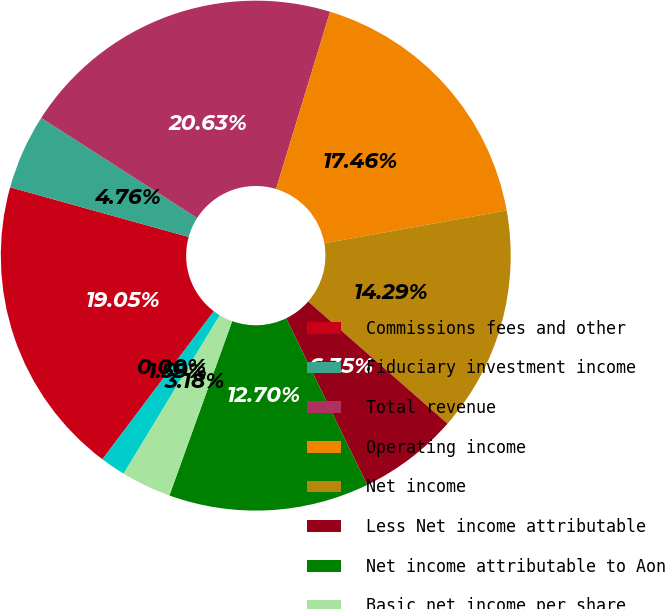<chart> <loc_0><loc_0><loc_500><loc_500><pie_chart><fcel>Commissions fees and other<fcel>Fiduciary investment income<fcel>Total revenue<fcel>Operating income<fcel>Net income<fcel>Less Net income attributable<fcel>Net income attributable to Aon<fcel>Basic net income per share<fcel>Diluted net income per share<fcel>Dividends paid per share<nl><fcel>19.05%<fcel>4.76%<fcel>20.63%<fcel>17.46%<fcel>14.29%<fcel>6.35%<fcel>12.7%<fcel>3.18%<fcel>1.59%<fcel>0.0%<nl></chart> 